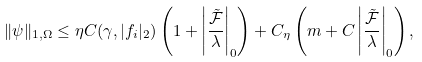<formula> <loc_0><loc_0><loc_500><loc_500>\| \psi \| _ { 1 , \Omega } \leq \eta C ( \gamma , | f _ { i } | _ { 2 } ) \left ( 1 + \left | \frac { \tilde { \mathcal { F } } } { \lambda } \right | _ { 0 } \right ) + C _ { \eta } \left ( m + C \left | \frac { \tilde { \mathcal { F } } } { \lambda } \right | _ { 0 } \right ) ,</formula> 